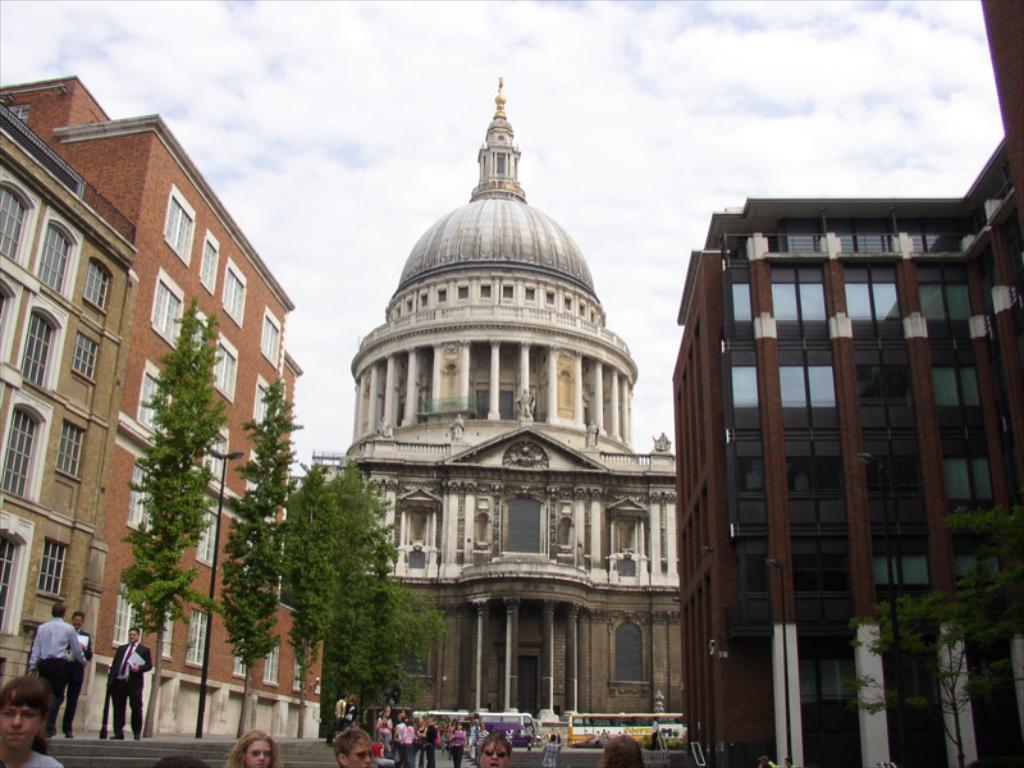Could you give a brief overview of what you see in this image? At the bottom of the image few people are standing and walking. Behind them there are some trees and vehicles. At the top of the image there are some buildings and clouds and sky. 